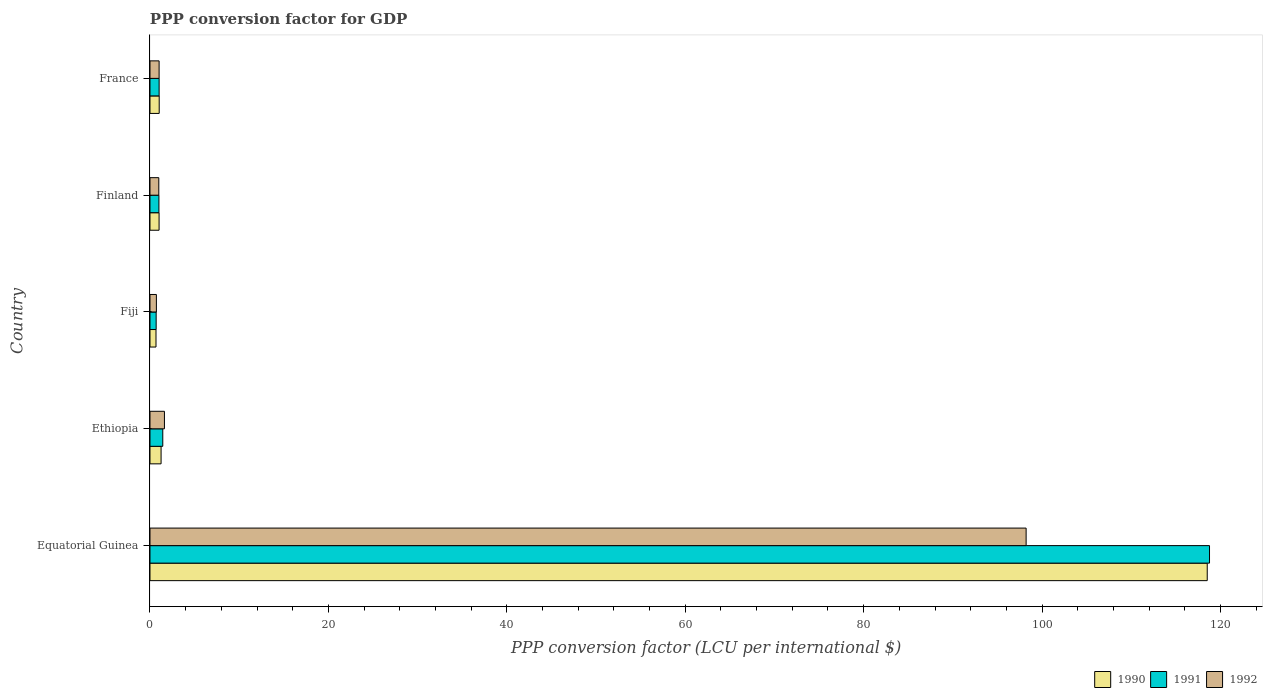How many different coloured bars are there?
Your answer should be compact. 3. How many groups of bars are there?
Give a very brief answer. 5. Are the number of bars on each tick of the Y-axis equal?
Keep it short and to the point. Yes. How many bars are there on the 5th tick from the top?
Make the answer very short. 3. What is the label of the 5th group of bars from the top?
Provide a succinct answer. Equatorial Guinea. What is the PPP conversion factor for GDP in 1992 in France?
Give a very brief answer. 1.02. Across all countries, what is the maximum PPP conversion factor for GDP in 1990?
Keep it short and to the point. 118.52. Across all countries, what is the minimum PPP conversion factor for GDP in 1990?
Ensure brevity in your answer.  0.67. In which country was the PPP conversion factor for GDP in 1990 maximum?
Your answer should be compact. Equatorial Guinea. In which country was the PPP conversion factor for GDP in 1990 minimum?
Your answer should be compact. Fiji. What is the total PPP conversion factor for GDP in 1990 in the graph?
Your answer should be compact. 122.49. What is the difference between the PPP conversion factor for GDP in 1991 in Equatorial Guinea and that in Ethiopia?
Your answer should be compact. 117.34. What is the difference between the PPP conversion factor for GDP in 1992 in Ethiopia and the PPP conversion factor for GDP in 1991 in Finland?
Provide a succinct answer. 0.62. What is the average PPP conversion factor for GDP in 1990 per country?
Your answer should be compact. 24.5. What is the difference between the PPP conversion factor for GDP in 1992 and PPP conversion factor for GDP in 1990 in Fiji?
Offer a very short reply. 0.04. In how many countries, is the PPP conversion factor for GDP in 1991 greater than 72 LCU?
Make the answer very short. 1. What is the ratio of the PPP conversion factor for GDP in 1990 in Fiji to that in Finland?
Your answer should be compact. 0.66. What is the difference between the highest and the second highest PPP conversion factor for GDP in 1991?
Your answer should be compact. 117.34. What is the difference between the highest and the lowest PPP conversion factor for GDP in 1992?
Your answer should be compact. 97.5. In how many countries, is the PPP conversion factor for GDP in 1990 greater than the average PPP conversion factor for GDP in 1990 taken over all countries?
Your response must be concise. 1. Is the sum of the PPP conversion factor for GDP in 1990 in Fiji and France greater than the maximum PPP conversion factor for GDP in 1992 across all countries?
Ensure brevity in your answer.  No. Are all the bars in the graph horizontal?
Ensure brevity in your answer.  Yes. How many countries are there in the graph?
Your answer should be very brief. 5. Are the values on the major ticks of X-axis written in scientific E-notation?
Ensure brevity in your answer.  No. Does the graph contain grids?
Offer a terse response. No. Where does the legend appear in the graph?
Provide a short and direct response. Bottom right. What is the title of the graph?
Your answer should be very brief. PPP conversion factor for GDP. What is the label or title of the X-axis?
Offer a very short reply. PPP conversion factor (LCU per international $). What is the PPP conversion factor (LCU per international $) in 1990 in Equatorial Guinea?
Your response must be concise. 118.52. What is the PPP conversion factor (LCU per international $) of 1991 in Equatorial Guinea?
Offer a very short reply. 118.77. What is the PPP conversion factor (LCU per international $) of 1992 in Equatorial Guinea?
Offer a terse response. 98.22. What is the PPP conversion factor (LCU per international $) of 1990 in Ethiopia?
Offer a very short reply. 1.24. What is the PPP conversion factor (LCU per international $) of 1991 in Ethiopia?
Your answer should be very brief. 1.43. What is the PPP conversion factor (LCU per international $) of 1992 in Ethiopia?
Provide a succinct answer. 1.62. What is the PPP conversion factor (LCU per international $) in 1990 in Fiji?
Your response must be concise. 0.67. What is the PPP conversion factor (LCU per international $) in 1991 in Fiji?
Provide a short and direct response. 0.69. What is the PPP conversion factor (LCU per international $) of 1992 in Fiji?
Provide a short and direct response. 0.72. What is the PPP conversion factor (LCU per international $) of 1990 in Finland?
Make the answer very short. 1.02. What is the PPP conversion factor (LCU per international $) in 1991 in Finland?
Make the answer very short. 1. What is the PPP conversion factor (LCU per international $) of 1992 in Finland?
Your answer should be very brief. 0.99. What is the PPP conversion factor (LCU per international $) of 1990 in France?
Your response must be concise. 1.03. What is the PPP conversion factor (LCU per international $) in 1991 in France?
Ensure brevity in your answer.  1.02. What is the PPP conversion factor (LCU per international $) of 1992 in France?
Offer a terse response. 1.02. Across all countries, what is the maximum PPP conversion factor (LCU per international $) of 1990?
Your answer should be compact. 118.52. Across all countries, what is the maximum PPP conversion factor (LCU per international $) in 1991?
Make the answer very short. 118.77. Across all countries, what is the maximum PPP conversion factor (LCU per international $) of 1992?
Your response must be concise. 98.22. Across all countries, what is the minimum PPP conversion factor (LCU per international $) of 1990?
Make the answer very short. 0.67. Across all countries, what is the minimum PPP conversion factor (LCU per international $) in 1991?
Your answer should be very brief. 0.69. Across all countries, what is the minimum PPP conversion factor (LCU per international $) of 1992?
Your answer should be compact. 0.72. What is the total PPP conversion factor (LCU per international $) in 1990 in the graph?
Offer a very short reply. 122.49. What is the total PPP conversion factor (LCU per international $) in 1991 in the graph?
Keep it short and to the point. 122.92. What is the total PPP conversion factor (LCU per international $) of 1992 in the graph?
Provide a short and direct response. 102.56. What is the difference between the PPP conversion factor (LCU per international $) in 1990 in Equatorial Guinea and that in Ethiopia?
Provide a short and direct response. 117.27. What is the difference between the PPP conversion factor (LCU per international $) of 1991 in Equatorial Guinea and that in Ethiopia?
Ensure brevity in your answer.  117.34. What is the difference between the PPP conversion factor (LCU per international $) in 1992 in Equatorial Guinea and that in Ethiopia?
Provide a short and direct response. 96.6. What is the difference between the PPP conversion factor (LCU per international $) of 1990 in Equatorial Guinea and that in Fiji?
Provide a succinct answer. 117.84. What is the difference between the PPP conversion factor (LCU per international $) of 1991 in Equatorial Guinea and that in Fiji?
Keep it short and to the point. 118.08. What is the difference between the PPP conversion factor (LCU per international $) in 1992 in Equatorial Guinea and that in Fiji?
Keep it short and to the point. 97.5. What is the difference between the PPP conversion factor (LCU per international $) of 1990 in Equatorial Guinea and that in Finland?
Ensure brevity in your answer.  117.5. What is the difference between the PPP conversion factor (LCU per international $) in 1991 in Equatorial Guinea and that in Finland?
Offer a terse response. 117.77. What is the difference between the PPP conversion factor (LCU per international $) of 1992 in Equatorial Guinea and that in Finland?
Make the answer very short. 97.23. What is the difference between the PPP conversion factor (LCU per international $) of 1990 in Equatorial Guinea and that in France?
Give a very brief answer. 117.49. What is the difference between the PPP conversion factor (LCU per international $) of 1991 in Equatorial Guinea and that in France?
Your answer should be compact. 117.75. What is the difference between the PPP conversion factor (LCU per international $) in 1992 in Equatorial Guinea and that in France?
Offer a very short reply. 97.19. What is the difference between the PPP conversion factor (LCU per international $) of 1990 in Ethiopia and that in Fiji?
Your answer should be very brief. 0.57. What is the difference between the PPP conversion factor (LCU per international $) in 1991 in Ethiopia and that in Fiji?
Keep it short and to the point. 0.74. What is the difference between the PPP conversion factor (LCU per international $) in 1992 in Ethiopia and that in Fiji?
Your answer should be compact. 0.9. What is the difference between the PPP conversion factor (LCU per international $) of 1990 in Ethiopia and that in Finland?
Provide a succinct answer. 0.23. What is the difference between the PPP conversion factor (LCU per international $) in 1991 in Ethiopia and that in Finland?
Offer a very short reply. 0.43. What is the difference between the PPP conversion factor (LCU per international $) in 1992 in Ethiopia and that in Finland?
Provide a short and direct response. 0.63. What is the difference between the PPP conversion factor (LCU per international $) of 1990 in Ethiopia and that in France?
Provide a short and direct response. 0.21. What is the difference between the PPP conversion factor (LCU per international $) in 1991 in Ethiopia and that in France?
Provide a short and direct response. 0.41. What is the difference between the PPP conversion factor (LCU per international $) in 1992 in Ethiopia and that in France?
Keep it short and to the point. 0.6. What is the difference between the PPP conversion factor (LCU per international $) of 1990 in Fiji and that in Finland?
Offer a terse response. -0.34. What is the difference between the PPP conversion factor (LCU per international $) in 1991 in Fiji and that in Finland?
Provide a short and direct response. -0.31. What is the difference between the PPP conversion factor (LCU per international $) of 1992 in Fiji and that in Finland?
Offer a very short reply. -0.27. What is the difference between the PPP conversion factor (LCU per international $) in 1990 in Fiji and that in France?
Make the answer very short. -0.36. What is the difference between the PPP conversion factor (LCU per international $) of 1991 in Fiji and that in France?
Give a very brief answer. -0.33. What is the difference between the PPP conversion factor (LCU per international $) in 1992 in Fiji and that in France?
Make the answer very short. -0.3. What is the difference between the PPP conversion factor (LCU per international $) of 1990 in Finland and that in France?
Provide a short and direct response. -0.01. What is the difference between the PPP conversion factor (LCU per international $) in 1991 in Finland and that in France?
Provide a succinct answer. -0.02. What is the difference between the PPP conversion factor (LCU per international $) in 1992 in Finland and that in France?
Keep it short and to the point. -0.03. What is the difference between the PPP conversion factor (LCU per international $) of 1990 in Equatorial Guinea and the PPP conversion factor (LCU per international $) of 1991 in Ethiopia?
Offer a very short reply. 117.08. What is the difference between the PPP conversion factor (LCU per international $) of 1990 in Equatorial Guinea and the PPP conversion factor (LCU per international $) of 1992 in Ethiopia?
Give a very brief answer. 116.9. What is the difference between the PPP conversion factor (LCU per international $) of 1991 in Equatorial Guinea and the PPP conversion factor (LCU per international $) of 1992 in Ethiopia?
Your answer should be compact. 117.16. What is the difference between the PPP conversion factor (LCU per international $) of 1990 in Equatorial Guinea and the PPP conversion factor (LCU per international $) of 1991 in Fiji?
Offer a very short reply. 117.83. What is the difference between the PPP conversion factor (LCU per international $) in 1990 in Equatorial Guinea and the PPP conversion factor (LCU per international $) in 1992 in Fiji?
Provide a short and direct response. 117.8. What is the difference between the PPP conversion factor (LCU per international $) of 1991 in Equatorial Guinea and the PPP conversion factor (LCU per international $) of 1992 in Fiji?
Offer a very short reply. 118.06. What is the difference between the PPP conversion factor (LCU per international $) in 1990 in Equatorial Guinea and the PPP conversion factor (LCU per international $) in 1991 in Finland?
Your response must be concise. 117.52. What is the difference between the PPP conversion factor (LCU per international $) in 1990 in Equatorial Guinea and the PPP conversion factor (LCU per international $) in 1992 in Finland?
Ensure brevity in your answer.  117.53. What is the difference between the PPP conversion factor (LCU per international $) in 1991 in Equatorial Guinea and the PPP conversion factor (LCU per international $) in 1992 in Finland?
Keep it short and to the point. 117.79. What is the difference between the PPP conversion factor (LCU per international $) of 1990 in Equatorial Guinea and the PPP conversion factor (LCU per international $) of 1991 in France?
Offer a terse response. 117.49. What is the difference between the PPP conversion factor (LCU per international $) of 1990 in Equatorial Guinea and the PPP conversion factor (LCU per international $) of 1992 in France?
Provide a short and direct response. 117.5. What is the difference between the PPP conversion factor (LCU per international $) in 1991 in Equatorial Guinea and the PPP conversion factor (LCU per international $) in 1992 in France?
Make the answer very short. 117.75. What is the difference between the PPP conversion factor (LCU per international $) in 1990 in Ethiopia and the PPP conversion factor (LCU per international $) in 1991 in Fiji?
Your answer should be very brief. 0.55. What is the difference between the PPP conversion factor (LCU per international $) of 1990 in Ethiopia and the PPP conversion factor (LCU per international $) of 1992 in Fiji?
Offer a very short reply. 0.53. What is the difference between the PPP conversion factor (LCU per international $) of 1991 in Ethiopia and the PPP conversion factor (LCU per international $) of 1992 in Fiji?
Give a very brief answer. 0.72. What is the difference between the PPP conversion factor (LCU per international $) in 1990 in Ethiopia and the PPP conversion factor (LCU per international $) in 1991 in Finland?
Give a very brief answer. 0.24. What is the difference between the PPP conversion factor (LCU per international $) in 1990 in Ethiopia and the PPP conversion factor (LCU per international $) in 1992 in Finland?
Keep it short and to the point. 0.26. What is the difference between the PPP conversion factor (LCU per international $) in 1991 in Ethiopia and the PPP conversion factor (LCU per international $) in 1992 in Finland?
Provide a short and direct response. 0.45. What is the difference between the PPP conversion factor (LCU per international $) in 1990 in Ethiopia and the PPP conversion factor (LCU per international $) in 1991 in France?
Provide a succinct answer. 0.22. What is the difference between the PPP conversion factor (LCU per international $) of 1990 in Ethiopia and the PPP conversion factor (LCU per international $) of 1992 in France?
Provide a succinct answer. 0.22. What is the difference between the PPP conversion factor (LCU per international $) of 1991 in Ethiopia and the PPP conversion factor (LCU per international $) of 1992 in France?
Your answer should be very brief. 0.41. What is the difference between the PPP conversion factor (LCU per international $) in 1990 in Fiji and the PPP conversion factor (LCU per international $) in 1991 in Finland?
Your answer should be compact. -0.33. What is the difference between the PPP conversion factor (LCU per international $) in 1990 in Fiji and the PPP conversion factor (LCU per international $) in 1992 in Finland?
Provide a short and direct response. -0.31. What is the difference between the PPP conversion factor (LCU per international $) in 1991 in Fiji and the PPP conversion factor (LCU per international $) in 1992 in Finland?
Provide a succinct answer. -0.3. What is the difference between the PPP conversion factor (LCU per international $) in 1990 in Fiji and the PPP conversion factor (LCU per international $) in 1991 in France?
Make the answer very short. -0.35. What is the difference between the PPP conversion factor (LCU per international $) in 1990 in Fiji and the PPP conversion factor (LCU per international $) in 1992 in France?
Offer a very short reply. -0.35. What is the difference between the PPP conversion factor (LCU per international $) of 1991 in Fiji and the PPP conversion factor (LCU per international $) of 1992 in France?
Offer a very short reply. -0.33. What is the difference between the PPP conversion factor (LCU per international $) in 1990 in Finland and the PPP conversion factor (LCU per international $) in 1991 in France?
Make the answer very short. -0.01. What is the difference between the PPP conversion factor (LCU per international $) of 1990 in Finland and the PPP conversion factor (LCU per international $) of 1992 in France?
Provide a succinct answer. -0. What is the difference between the PPP conversion factor (LCU per international $) of 1991 in Finland and the PPP conversion factor (LCU per international $) of 1992 in France?
Your answer should be very brief. -0.02. What is the average PPP conversion factor (LCU per international $) of 1990 per country?
Your answer should be very brief. 24.5. What is the average PPP conversion factor (LCU per international $) of 1991 per country?
Your response must be concise. 24.58. What is the average PPP conversion factor (LCU per international $) in 1992 per country?
Keep it short and to the point. 20.51. What is the difference between the PPP conversion factor (LCU per international $) of 1990 and PPP conversion factor (LCU per international $) of 1991 in Equatorial Guinea?
Give a very brief answer. -0.26. What is the difference between the PPP conversion factor (LCU per international $) in 1990 and PPP conversion factor (LCU per international $) in 1992 in Equatorial Guinea?
Provide a short and direct response. 20.3. What is the difference between the PPP conversion factor (LCU per international $) in 1991 and PPP conversion factor (LCU per international $) in 1992 in Equatorial Guinea?
Offer a terse response. 20.56. What is the difference between the PPP conversion factor (LCU per international $) of 1990 and PPP conversion factor (LCU per international $) of 1991 in Ethiopia?
Offer a very short reply. -0.19. What is the difference between the PPP conversion factor (LCU per international $) of 1990 and PPP conversion factor (LCU per international $) of 1992 in Ethiopia?
Your answer should be very brief. -0.38. What is the difference between the PPP conversion factor (LCU per international $) in 1991 and PPP conversion factor (LCU per international $) in 1992 in Ethiopia?
Your response must be concise. -0.19. What is the difference between the PPP conversion factor (LCU per international $) in 1990 and PPP conversion factor (LCU per international $) in 1991 in Fiji?
Your answer should be compact. -0.02. What is the difference between the PPP conversion factor (LCU per international $) of 1990 and PPP conversion factor (LCU per international $) of 1992 in Fiji?
Offer a very short reply. -0.04. What is the difference between the PPP conversion factor (LCU per international $) in 1991 and PPP conversion factor (LCU per international $) in 1992 in Fiji?
Give a very brief answer. -0.03. What is the difference between the PPP conversion factor (LCU per international $) in 1990 and PPP conversion factor (LCU per international $) in 1991 in Finland?
Keep it short and to the point. 0.02. What is the difference between the PPP conversion factor (LCU per international $) of 1990 and PPP conversion factor (LCU per international $) of 1992 in Finland?
Make the answer very short. 0.03. What is the difference between the PPP conversion factor (LCU per international $) of 1991 and PPP conversion factor (LCU per international $) of 1992 in Finland?
Offer a very short reply. 0.01. What is the difference between the PPP conversion factor (LCU per international $) of 1990 and PPP conversion factor (LCU per international $) of 1991 in France?
Your answer should be very brief. 0.01. What is the difference between the PPP conversion factor (LCU per international $) of 1990 and PPP conversion factor (LCU per international $) of 1992 in France?
Your answer should be very brief. 0.01. What is the difference between the PPP conversion factor (LCU per international $) of 1991 and PPP conversion factor (LCU per international $) of 1992 in France?
Provide a short and direct response. 0. What is the ratio of the PPP conversion factor (LCU per international $) in 1990 in Equatorial Guinea to that in Ethiopia?
Give a very brief answer. 95.29. What is the ratio of the PPP conversion factor (LCU per international $) of 1991 in Equatorial Guinea to that in Ethiopia?
Offer a very short reply. 82.86. What is the ratio of the PPP conversion factor (LCU per international $) in 1992 in Equatorial Guinea to that in Ethiopia?
Offer a terse response. 60.66. What is the ratio of the PPP conversion factor (LCU per international $) in 1990 in Equatorial Guinea to that in Fiji?
Your response must be concise. 175.93. What is the ratio of the PPP conversion factor (LCU per international $) in 1991 in Equatorial Guinea to that in Fiji?
Your answer should be very brief. 171.88. What is the ratio of the PPP conversion factor (LCU per international $) of 1992 in Equatorial Guinea to that in Fiji?
Keep it short and to the point. 136.8. What is the ratio of the PPP conversion factor (LCU per international $) of 1990 in Equatorial Guinea to that in Finland?
Your response must be concise. 116.41. What is the ratio of the PPP conversion factor (LCU per international $) in 1991 in Equatorial Guinea to that in Finland?
Ensure brevity in your answer.  118.7. What is the ratio of the PPP conversion factor (LCU per international $) of 1992 in Equatorial Guinea to that in Finland?
Provide a succinct answer. 99.47. What is the ratio of the PPP conversion factor (LCU per international $) of 1990 in Equatorial Guinea to that in France?
Keep it short and to the point. 114.81. What is the ratio of the PPP conversion factor (LCU per international $) in 1991 in Equatorial Guinea to that in France?
Provide a succinct answer. 115.91. What is the ratio of the PPP conversion factor (LCU per international $) of 1992 in Equatorial Guinea to that in France?
Make the answer very short. 96.12. What is the ratio of the PPP conversion factor (LCU per international $) of 1990 in Ethiopia to that in Fiji?
Make the answer very short. 1.85. What is the ratio of the PPP conversion factor (LCU per international $) of 1991 in Ethiopia to that in Fiji?
Your response must be concise. 2.07. What is the ratio of the PPP conversion factor (LCU per international $) of 1992 in Ethiopia to that in Fiji?
Your response must be concise. 2.26. What is the ratio of the PPP conversion factor (LCU per international $) in 1990 in Ethiopia to that in Finland?
Ensure brevity in your answer.  1.22. What is the ratio of the PPP conversion factor (LCU per international $) of 1991 in Ethiopia to that in Finland?
Provide a short and direct response. 1.43. What is the ratio of the PPP conversion factor (LCU per international $) of 1992 in Ethiopia to that in Finland?
Provide a succinct answer. 1.64. What is the ratio of the PPP conversion factor (LCU per international $) in 1990 in Ethiopia to that in France?
Offer a terse response. 1.2. What is the ratio of the PPP conversion factor (LCU per international $) of 1991 in Ethiopia to that in France?
Offer a terse response. 1.4. What is the ratio of the PPP conversion factor (LCU per international $) of 1992 in Ethiopia to that in France?
Provide a succinct answer. 1.58. What is the ratio of the PPP conversion factor (LCU per international $) in 1990 in Fiji to that in Finland?
Offer a very short reply. 0.66. What is the ratio of the PPP conversion factor (LCU per international $) of 1991 in Fiji to that in Finland?
Provide a short and direct response. 0.69. What is the ratio of the PPP conversion factor (LCU per international $) of 1992 in Fiji to that in Finland?
Provide a short and direct response. 0.73. What is the ratio of the PPP conversion factor (LCU per international $) of 1990 in Fiji to that in France?
Your response must be concise. 0.65. What is the ratio of the PPP conversion factor (LCU per international $) of 1991 in Fiji to that in France?
Give a very brief answer. 0.67. What is the ratio of the PPP conversion factor (LCU per international $) in 1992 in Fiji to that in France?
Your answer should be compact. 0.7. What is the ratio of the PPP conversion factor (LCU per international $) in 1990 in Finland to that in France?
Ensure brevity in your answer.  0.99. What is the ratio of the PPP conversion factor (LCU per international $) of 1991 in Finland to that in France?
Ensure brevity in your answer.  0.98. What is the ratio of the PPP conversion factor (LCU per international $) in 1992 in Finland to that in France?
Ensure brevity in your answer.  0.97. What is the difference between the highest and the second highest PPP conversion factor (LCU per international $) in 1990?
Offer a terse response. 117.27. What is the difference between the highest and the second highest PPP conversion factor (LCU per international $) of 1991?
Offer a very short reply. 117.34. What is the difference between the highest and the second highest PPP conversion factor (LCU per international $) of 1992?
Give a very brief answer. 96.6. What is the difference between the highest and the lowest PPP conversion factor (LCU per international $) of 1990?
Your answer should be compact. 117.84. What is the difference between the highest and the lowest PPP conversion factor (LCU per international $) in 1991?
Provide a short and direct response. 118.08. What is the difference between the highest and the lowest PPP conversion factor (LCU per international $) in 1992?
Provide a short and direct response. 97.5. 